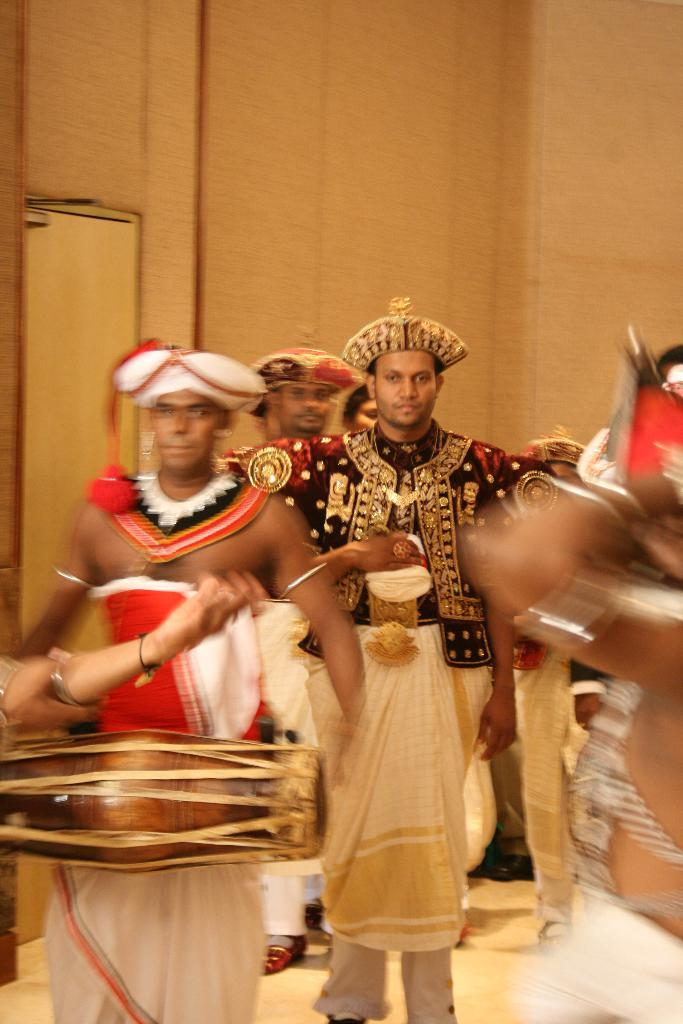What is the main subject of the image? There is a person standing at the center of the image. What are the people on the left side of the person doing? People are playing drums on the left side of the person. What are the people on the right side of the person doing? People are playing drums on the right side of the person. What is the name of the police officer in the image? There is no police officer present in the image. How is the person in the image measuring the distance between the drums? The image does not show any measuring tools or actions related to measuring distance. 